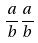<formula> <loc_0><loc_0><loc_500><loc_500>\frac { a } { b } \frac { a } { b }</formula> 